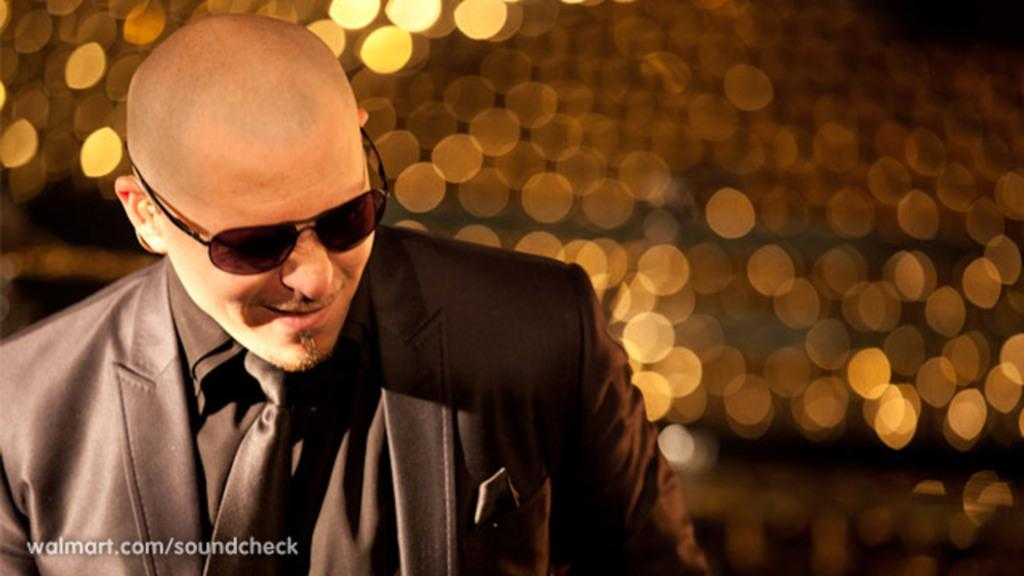Who or what is present in the image? There is a person in the image. What is the person wearing? The person is wearing goggles. What can be seen in the background of the image? There are lights in the background of the image. How would you describe the appearance of the lights? The lights appear blurry. Is there any additional information or marking in the image? Yes, there is a watermark in the bottom left corner of the image. What type of mass can be seen floating in the air in the image? There is no mass floating in the air in the image; it only features a person wearing goggles and lights in the background. 